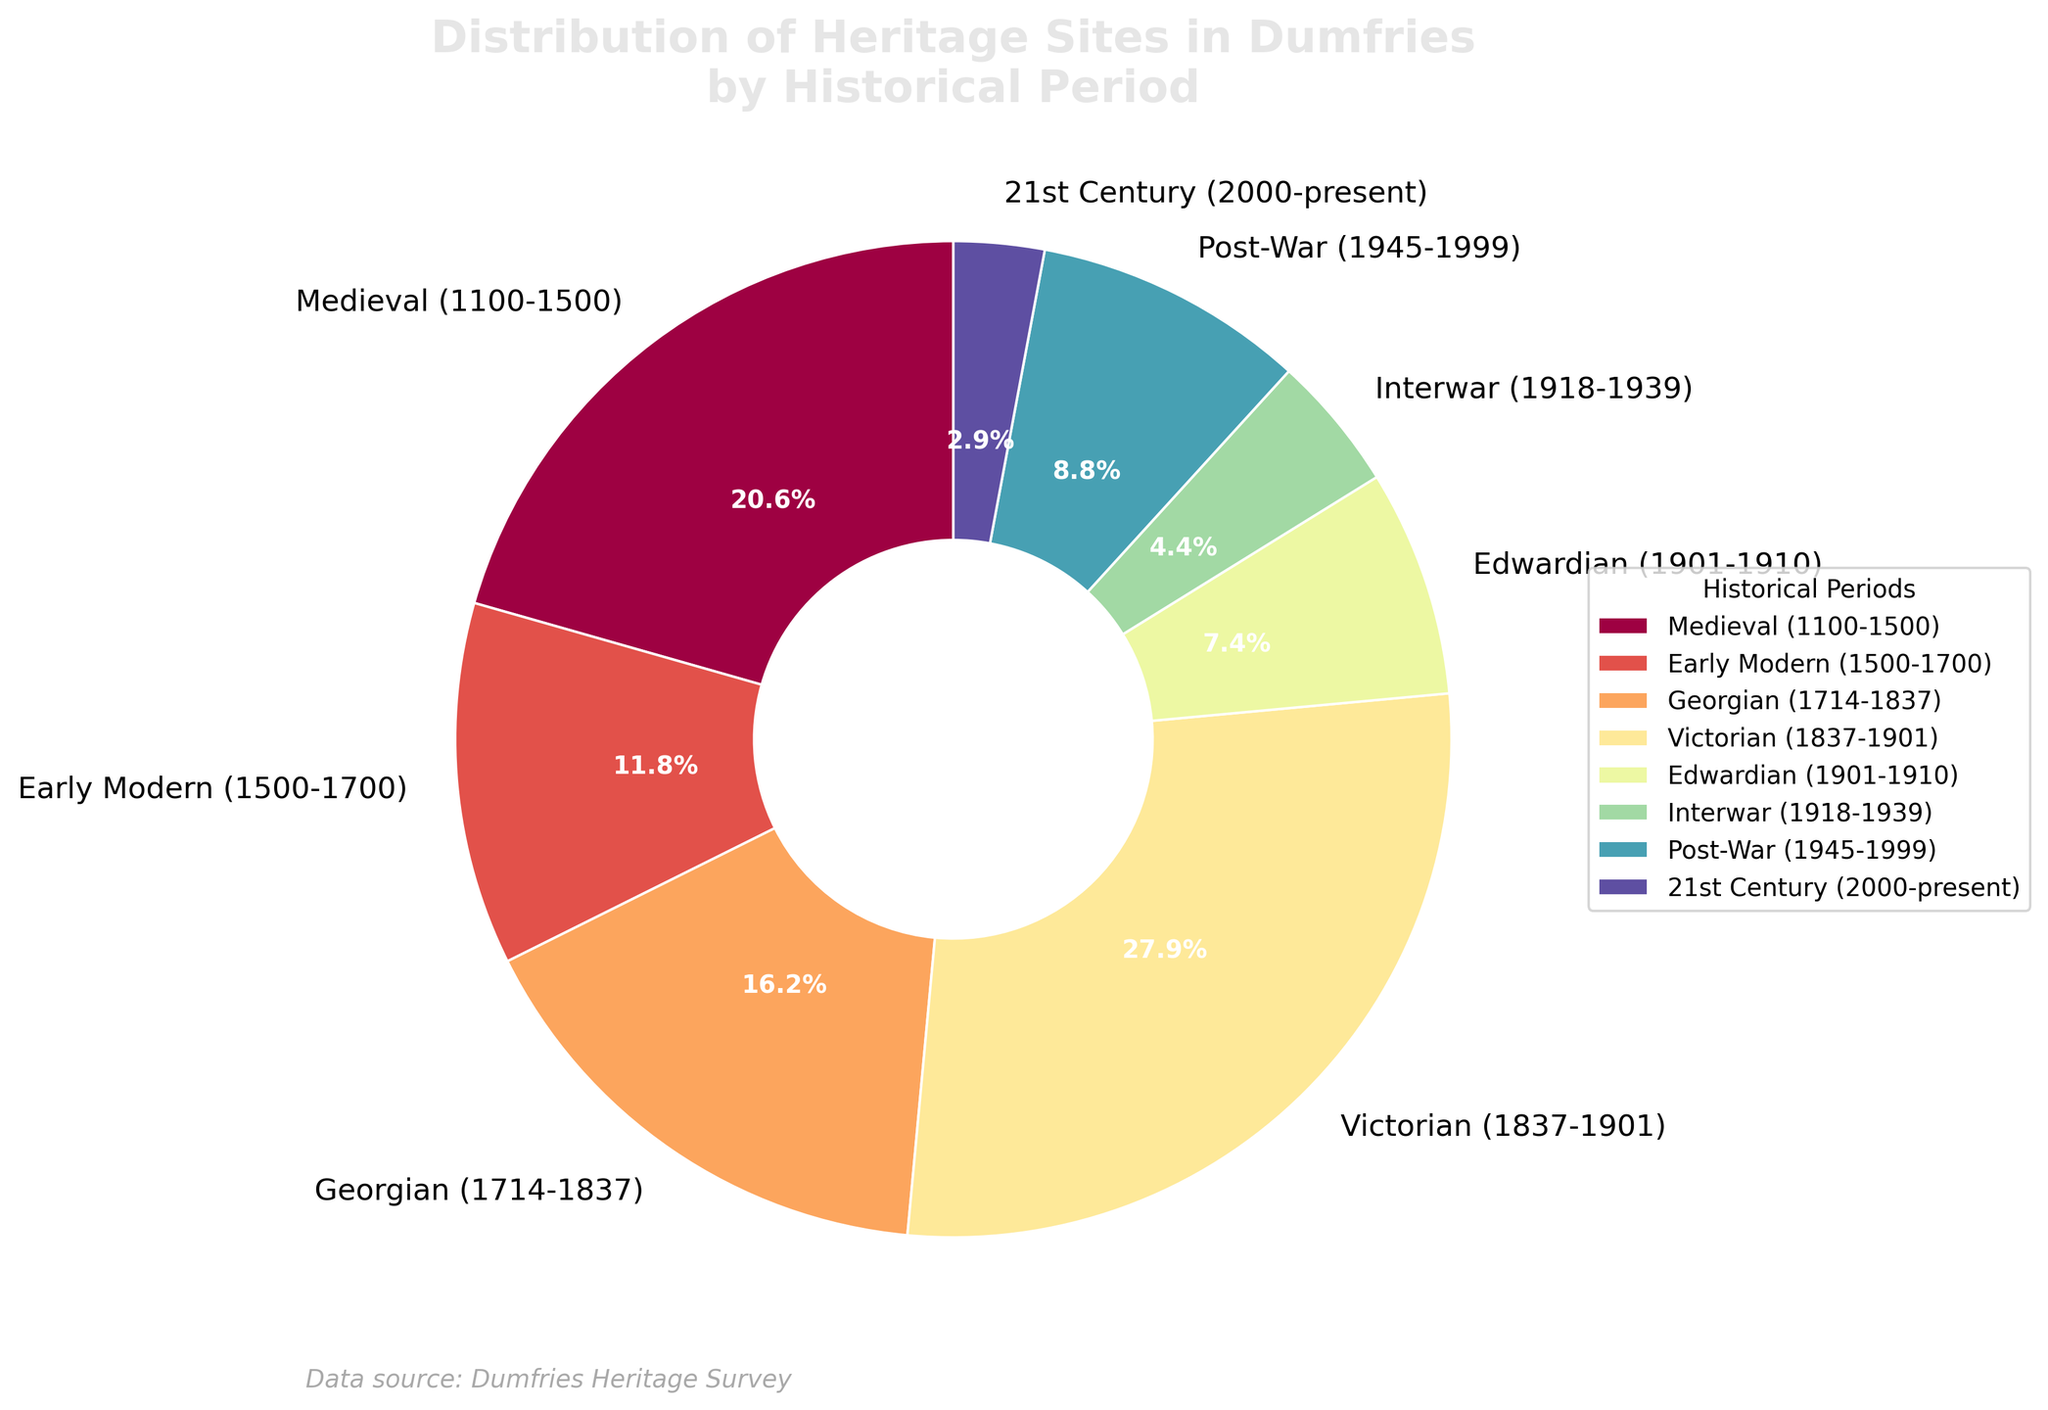Which historical period has the highest number of heritage sites? The figure shows that the Victorian period has the largest section of the pie chart. This indicates that the Victorian period has the highest number of heritage sites.
Answer: Victorian (1837-1901) How many more heritage sites are there from the Victorian period compared to the Edwardian period? The Victorian period has 19 heritage sites, and the Edwardian period has 5 heritage sites. The difference is 19 - 5 = 14 heritage sites.
Answer: 14 Which historical period has the smallest proportion of heritage sites? The pie chart indicates the smallest section belongs to the 21st Century period, which signifies that it has the smallest proportion of heritage sites.
Answer: 21st Century (2000-present) What percentage of the total heritage sites does the Medieval period represent? The Medieval period section is labeled with a percentage on the pie chart. According to the chart, the Medieval period represents 14.0% of the total heritage sites.
Answer: 14.0% Compare the number of heritage sites in the Georgian and Post-War periods. Which one has more and by how much? The Georgian period has 11 heritage sites while the Post-War period has 6 heritage sites. The Georgian period has 11 - 6 = 5 more heritage sites than the Post-War period.
Answer: Georgian period has 5 more What is the total number of heritage sites represented in the pie chart? Sum the number of heritage sites across all periods: 14 (Medieval) + 8 (Early Modern) + 11 (Georgian) + 19 (Victorian) + 5 (Edwardian) + 3 (Interwar) + 6 (Post-War) + 2 (21st Century) = 68.
Answer: 68 If we combine the heritage sites from the Interwar, Post-War, and 21st Century periods, what is their combined total? Add the number of heritage sites from the Interwar (3), Post-War (6), and 21st Century (2) periods: 3 + 6 + 2 = 11.
Answer: 11 What is the difference in the proportion of heritage sites between the Early Modern and Georgian periods? The pie chart shows that the Early Modern period represents 11.8% and the Georgian period represents 16.2%. The difference is 16.2% - 11.8% = 4.4%.
Answer: 4.4% How does the proportion of heritage sites from the Georgian period compare to the sum of the Interwar and Post-War periods’ proportions? The Georgian period is 16.2%. The sum of the Interwar (4.4%) and Post-War (8.8%) periods’ proportions is 4.4% + 8.8% = 13.2%. 16.2% is greater than 13.2%.
Answer: Georgian period is greater by 3.0% Rank the periods in descending order based on the number of heritage sites they represent. From the highest to the lowest number of heritage sites: Victorian (19), Medieval (14), Georgian (11), Early Modern (8), Post-War (6), Edwardian (5), Interwar (3), 21st Century (2).
Answer: Victorian, Medieval, Georgian, Early Modern, Post-War, Edwardian, Interwar, 21st Century 